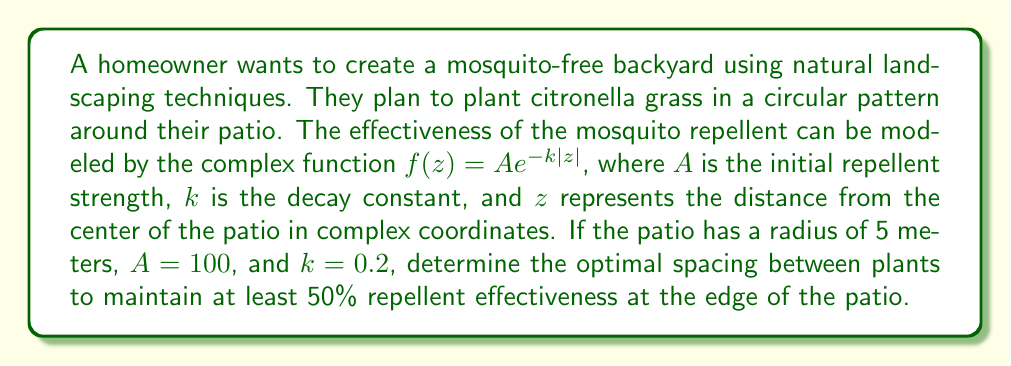Give your solution to this math problem. To solve this problem, we'll follow these steps:

1) The repellent effectiveness at the edge of the patio is given by $f(z)$ where $|z| = 5$ (the radius of the patio).

2) We want this effectiveness to be at least 50% of the initial strength. So we need to solve:

   $$f(5) = Ae^{-k|z|} \geq 0.5A$$

3) Substituting the given values:

   $$100e^{-0.2 \cdot 5} \geq 0.5 \cdot 100$$

4) Simplifying:

   $$e^{-1} \geq 0.5$$

5) Taking the natural log of both sides:

   $$-1 \geq \ln(0.5)$$

6) This inequality is indeed true (-1 ≈ -0.693), confirming that the repellent is more than 50% effective at the edge of the patio.

7) To find the optimal spacing, we need to determine where the effectiveness drops to exactly 50%:

   $$100e^{-0.2r} = 50$$

8) Solving for r:

   $$e^{-0.2r} = 0.5$$
   $$-0.2r = \ln(0.5)$$
   $$r = -\frac{\ln(0.5)}{0.2} \approx 3.47$$

9) This means the repellent is 50% effective at about 3.47 meters from the center.

10) The optimal spacing between plants should be the difference between this distance and the patio radius:

    $$5 - 3.47 = 1.53$$

Therefore, the plants should be spaced approximately 1.53 meters apart along the circumference of the patio for optimal effectiveness.
Answer: The optimal spacing between citronella grass plants should be approximately 1.53 meters. 